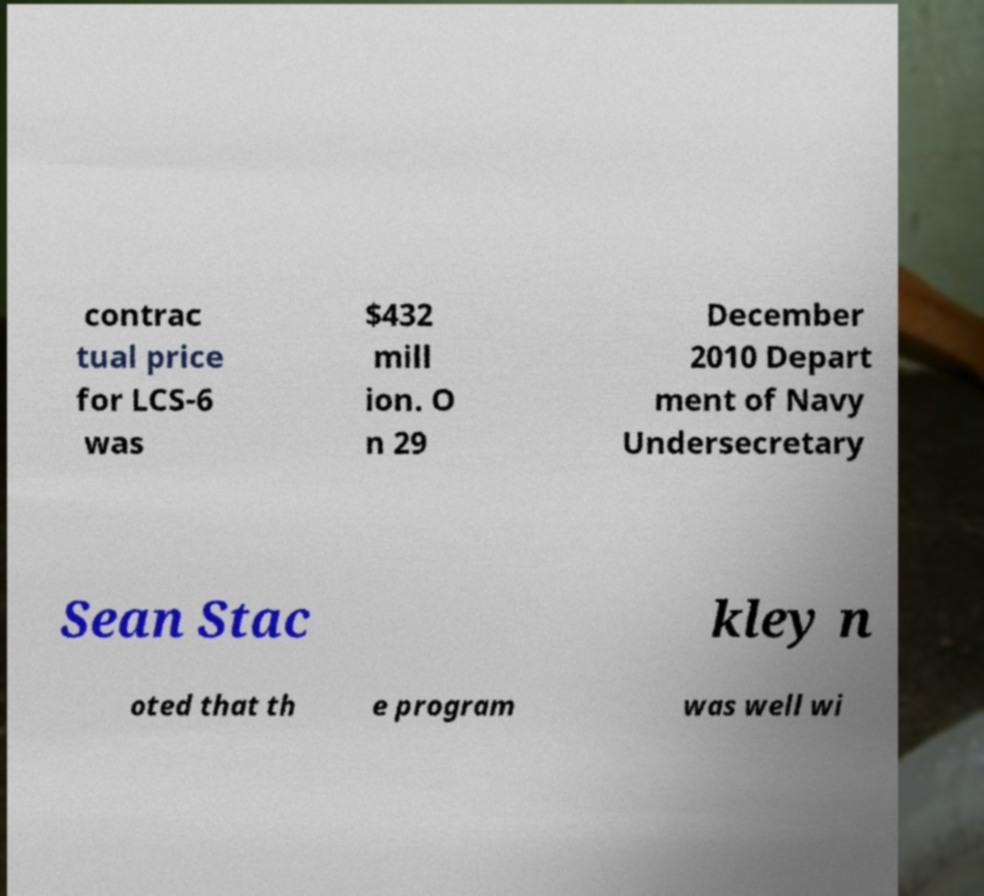Can you accurately transcribe the text from the provided image for me? contrac tual price for LCS-6 was $432 mill ion. O n 29 December 2010 Depart ment of Navy Undersecretary Sean Stac kley n oted that th e program was well wi 